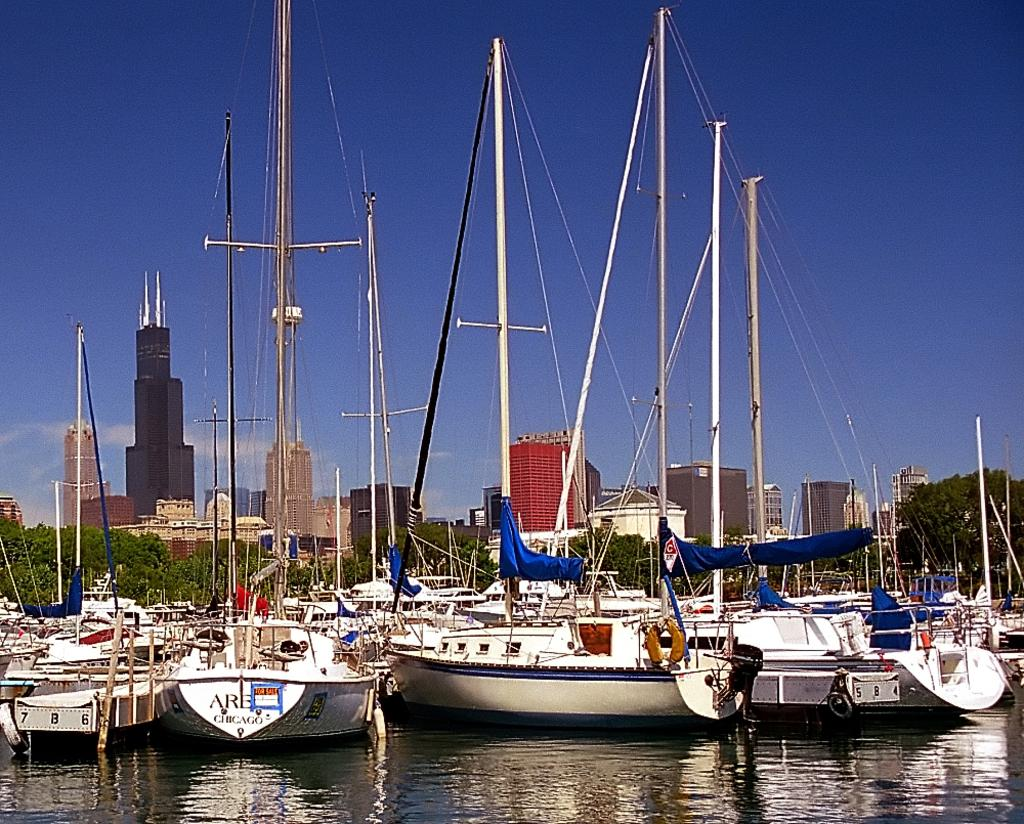<image>
Present a compact description of the photo's key features. A boat with Chicago on the back also has a for sale sign on it. 